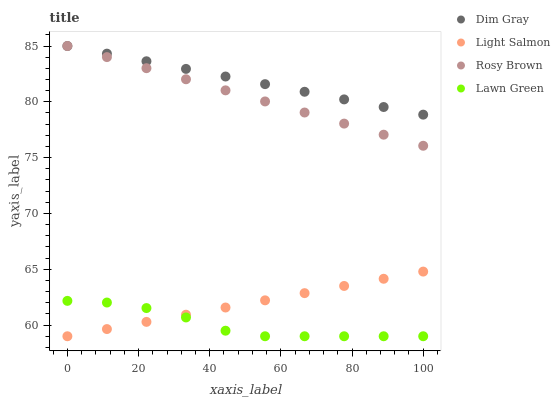Does Lawn Green have the minimum area under the curve?
Answer yes or no. Yes. Does Dim Gray have the maximum area under the curve?
Answer yes or no. Yes. Does Light Salmon have the minimum area under the curve?
Answer yes or no. No. Does Light Salmon have the maximum area under the curve?
Answer yes or no. No. Is Dim Gray the smoothest?
Answer yes or no. Yes. Is Lawn Green the roughest?
Answer yes or no. Yes. Is Light Salmon the smoothest?
Answer yes or no. No. Is Light Salmon the roughest?
Answer yes or no. No. Does Lawn Green have the lowest value?
Answer yes or no. Yes. Does Dim Gray have the lowest value?
Answer yes or no. No. Does Rosy Brown have the highest value?
Answer yes or no. Yes. Does Light Salmon have the highest value?
Answer yes or no. No. Is Lawn Green less than Rosy Brown?
Answer yes or no. Yes. Is Dim Gray greater than Light Salmon?
Answer yes or no. Yes. Does Light Salmon intersect Lawn Green?
Answer yes or no. Yes. Is Light Salmon less than Lawn Green?
Answer yes or no. No. Is Light Salmon greater than Lawn Green?
Answer yes or no. No. Does Lawn Green intersect Rosy Brown?
Answer yes or no. No. 